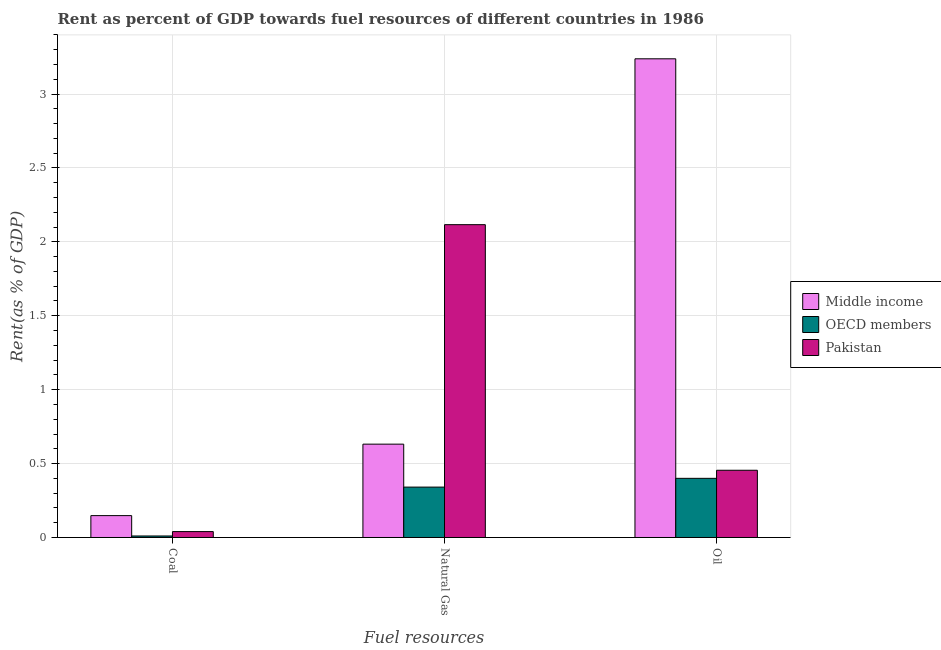How many different coloured bars are there?
Ensure brevity in your answer.  3. How many groups of bars are there?
Your response must be concise. 3. Are the number of bars on each tick of the X-axis equal?
Make the answer very short. Yes. How many bars are there on the 1st tick from the left?
Your answer should be very brief. 3. How many bars are there on the 1st tick from the right?
Keep it short and to the point. 3. What is the label of the 1st group of bars from the left?
Offer a terse response. Coal. What is the rent towards oil in Middle income?
Make the answer very short. 3.24. Across all countries, what is the maximum rent towards oil?
Keep it short and to the point. 3.24. Across all countries, what is the minimum rent towards oil?
Your response must be concise. 0.4. In which country was the rent towards coal maximum?
Keep it short and to the point. Middle income. What is the total rent towards coal in the graph?
Your response must be concise. 0.2. What is the difference between the rent towards oil in OECD members and that in Pakistan?
Give a very brief answer. -0.05. What is the difference between the rent towards coal in Pakistan and the rent towards natural gas in OECD members?
Your answer should be compact. -0.3. What is the average rent towards coal per country?
Keep it short and to the point. 0.07. What is the difference between the rent towards oil and rent towards natural gas in Pakistan?
Offer a terse response. -1.66. What is the ratio of the rent towards natural gas in Pakistan to that in Middle income?
Make the answer very short. 3.35. What is the difference between the highest and the second highest rent towards coal?
Give a very brief answer. 0.11. What is the difference between the highest and the lowest rent towards coal?
Ensure brevity in your answer.  0.14. In how many countries, is the rent towards oil greater than the average rent towards oil taken over all countries?
Offer a very short reply. 1. What does the 2nd bar from the right in Oil represents?
Your answer should be very brief. OECD members. Is it the case that in every country, the sum of the rent towards coal and rent towards natural gas is greater than the rent towards oil?
Give a very brief answer. No. How many bars are there?
Give a very brief answer. 9. How many countries are there in the graph?
Make the answer very short. 3. Does the graph contain any zero values?
Provide a succinct answer. No. Does the graph contain grids?
Your answer should be compact. Yes. How many legend labels are there?
Ensure brevity in your answer.  3. How are the legend labels stacked?
Offer a terse response. Vertical. What is the title of the graph?
Provide a short and direct response. Rent as percent of GDP towards fuel resources of different countries in 1986. What is the label or title of the X-axis?
Your answer should be very brief. Fuel resources. What is the label or title of the Y-axis?
Offer a terse response. Rent(as % of GDP). What is the Rent(as % of GDP) of Middle income in Coal?
Your answer should be compact. 0.15. What is the Rent(as % of GDP) in OECD members in Coal?
Give a very brief answer. 0.01. What is the Rent(as % of GDP) of Pakistan in Coal?
Offer a terse response. 0.04. What is the Rent(as % of GDP) of Middle income in Natural Gas?
Your answer should be compact. 0.63. What is the Rent(as % of GDP) of OECD members in Natural Gas?
Ensure brevity in your answer.  0.34. What is the Rent(as % of GDP) in Pakistan in Natural Gas?
Provide a short and direct response. 2.12. What is the Rent(as % of GDP) of Middle income in Oil?
Ensure brevity in your answer.  3.24. What is the Rent(as % of GDP) of OECD members in Oil?
Your answer should be compact. 0.4. What is the Rent(as % of GDP) in Pakistan in Oil?
Offer a very short reply. 0.45. Across all Fuel resources, what is the maximum Rent(as % of GDP) of Middle income?
Offer a very short reply. 3.24. Across all Fuel resources, what is the maximum Rent(as % of GDP) in OECD members?
Keep it short and to the point. 0.4. Across all Fuel resources, what is the maximum Rent(as % of GDP) in Pakistan?
Your answer should be compact. 2.12. Across all Fuel resources, what is the minimum Rent(as % of GDP) of Middle income?
Make the answer very short. 0.15. Across all Fuel resources, what is the minimum Rent(as % of GDP) of OECD members?
Give a very brief answer. 0.01. Across all Fuel resources, what is the minimum Rent(as % of GDP) in Pakistan?
Provide a succinct answer. 0.04. What is the total Rent(as % of GDP) in Middle income in the graph?
Provide a short and direct response. 4.02. What is the total Rent(as % of GDP) of OECD members in the graph?
Ensure brevity in your answer.  0.75. What is the total Rent(as % of GDP) in Pakistan in the graph?
Offer a very short reply. 2.61. What is the difference between the Rent(as % of GDP) of Middle income in Coal and that in Natural Gas?
Your answer should be compact. -0.48. What is the difference between the Rent(as % of GDP) in OECD members in Coal and that in Natural Gas?
Give a very brief answer. -0.33. What is the difference between the Rent(as % of GDP) of Pakistan in Coal and that in Natural Gas?
Provide a succinct answer. -2.08. What is the difference between the Rent(as % of GDP) in Middle income in Coal and that in Oil?
Your answer should be very brief. -3.09. What is the difference between the Rent(as % of GDP) of OECD members in Coal and that in Oil?
Provide a succinct answer. -0.39. What is the difference between the Rent(as % of GDP) of Pakistan in Coal and that in Oil?
Your answer should be very brief. -0.41. What is the difference between the Rent(as % of GDP) in Middle income in Natural Gas and that in Oil?
Provide a short and direct response. -2.61. What is the difference between the Rent(as % of GDP) of OECD members in Natural Gas and that in Oil?
Your response must be concise. -0.06. What is the difference between the Rent(as % of GDP) in Pakistan in Natural Gas and that in Oil?
Offer a terse response. 1.66. What is the difference between the Rent(as % of GDP) of Middle income in Coal and the Rent(as % of GDP) of OECD members in Natural Gas?
Give a very brief answer. -0.19. What is the difference between the Rent(as % of GDP) in Middle income in Coal and the Rent(as % of GDP) in Pakistan in Natural Gas?
Offer a very short reply. -1.97. What is the difference between the Rent(as % of GDP) of OECD members in Coal and the Rent(as % of GDP) of Pakistan in Natural Gas?
Offer a very short reply. -2.11. What is the difference between the Rent(as % of GDP) of Middle income in Coal and the Rent(as % of GDP) of OECD members in Oil?
Provide a succinct answer. -0.25. What is the difference between the Rent(as % of GDP) in Middle income in Coal and the Rent(as % of GDP) in Pakistan in Oil?
Offer a terse response. -0.31. What is the difference between the Rent(as % of GDP) in OECD members in Coal and the Rent(as % of GDP) in Pakistan in Oil?
Ensure brevity in your answer.  -0.44. What is the difference between the Rent(as % of GDP) of Middle income in Natural Gas and the Rent(as % of GDP) of OECD members in Oil?
Give a very brief answer. 0.23. What is the difference between the Rent(as % of GDP) in Middle income in Natural Gas and the Rent(as % of GDP) in Pakistan in Oil?
Give a very brief answer. 0.18. What is the difference between the Rent(as % of GDP) in OECD members in Natural Gas and the Rent(as % of GDP) in Pakistan in Oil?
Offer a terse response. -0.11. What is the average Rent(as % of GDP) of Middle income per Fuel resources?
Give a very brief answer. 1.34. What is the average Rent(as % of GDP) of OECD members per Fuel resources?
Offer a very short reply. 0.25. What is the average Rent(as % of GDP) of Pakistan per Fuel resources?
Keep it short and to the point. 0.87. What is the difference between the Rent(as % of GDP) of Middle income and Rent(as % of GDP) of OECD members in Coal?
Your answer should be very brief. 0.14. What is the difference between the Rent(as % of GDP) in Middle income and Rent(as % of GDP) in Pakistan in Coal?
Offer a terse response. 0.11. What is the difference between the Rent(as % of GDP) of OECD members and Rent(as % of GDP) of Pakistan in Coal?
Offer a very short reply. -0.03. What is the difference between the Rent(as % of GDP) of Middle income and Rent(as % of GDP) of OECD members in Natural Gas?
Your response must be concise. 0.29. What is the difference between the Rent(as % of GDP) of Middle income and Rent(as % of GDP) of Pakistan in Natural Gas?
Provide a succinct answer. -1.48. What is the difference between the Rent(as % of GDP) in OECD members and Rent(as % of GDP) in Pakistan in Natural Gas?
Your answer should be compact. -1.78. What is the difference between the Rent(as % of GDP) of Middle income and Rent(as % of GDP) of OECD members in Oil?
Ensure brevity in your answer.  2.84. What is the difference between the Rent(as % of GDP) of Middle income and Rent(as % of GDP) of Pakistan in Oil?
Your answer should be compact. 2.78. What is the difference between the Rent(as % of GDP) of OECD members and Rent(as % of GDP) of Pakistan in Oil?
Make the answer very short. -0.05. What is the ratio of the Rent(as % of GDP) of Middle income in Coal to that in Natural Gas?
Your answer should be compact. 0.23. What is the ratio of the Rent(as % of GDP) of OECD members in Coal to that in Natural Gas?
Provide a short and direct response. 0.03. What is the ratio of the Rent(as % of GDP) in Pakistan in Coal to that in Natural Gas?
Provide a succinct answer. 0.02. What is the ratio of the Rent(as % of GDP) in Middle income in Coal to that in Oil?
Offer a very short reply. 0.05. What is the ratio of the Rent(as % of GDP) in OECD members in Coal to that in Oil?
Give a very brief answer. 0.03. What is the ratio of the Rent(as % of GDP) of Pakistan in Coal to that in Oil?
Make the answer very short. 0.09. What is the ratio of the Rent(as % of GDP) in Middle income in Natural Gas to that in Oil?
Make the answer very short. 0.2. What is the ratio of the Rent(as % of GDP) of OECD members in Natural Gas to that in Oil?
Your answer should be very brief. 0.85. What is the ratio of the Rent(as % of GDP) of Pakistan in Natural Gas to that in Oil?
Provide a succinct answer. 4.65. What is the difference between the highest and the second highest Rent(as % of GDP) of Middle income?
Provide a succinct answer. 2.61. What is the difference between the highest and the second highest Rent(as % of GDP) in OECD members?
Provide a succinct answer. 0.06. What is the difference between the highest and the second highest Rent(as % of GDP) of Pakistan?
Provide a succinct answer. 1.66. What is the difference between the highest and the lowest Rent(as % of GDP) in Middle income?
Make the answer very short. 3.09. What is the difference between the highest and the lowest Rent(as % of GDP) in OECD members?
Provide a short and direct response. 0.39. What is the difference between the highest and the lowest Rent(as % of GDP) in Pakistan?
Your answer should be very brief. 2.08. 